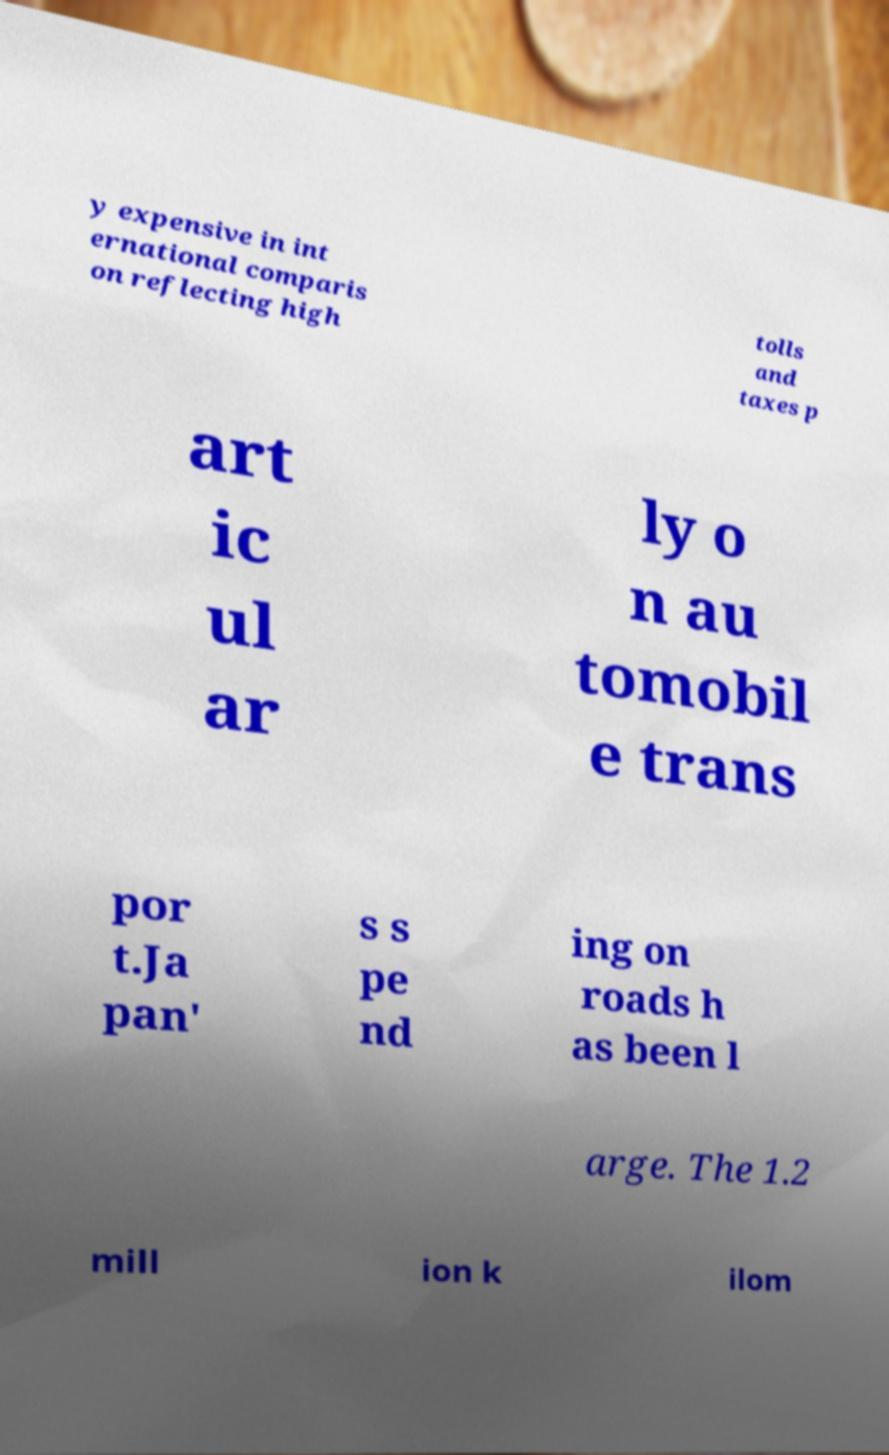Could you extract and type out the text from this image? y expensive in int ernational comparis on reflecting high tolls and taxes p art ic ul ar ly o n au tomobil e trans por t.Ja pan' s s pe nd ing on roads h as been l arge. The 1.2 mill ion k ilom 